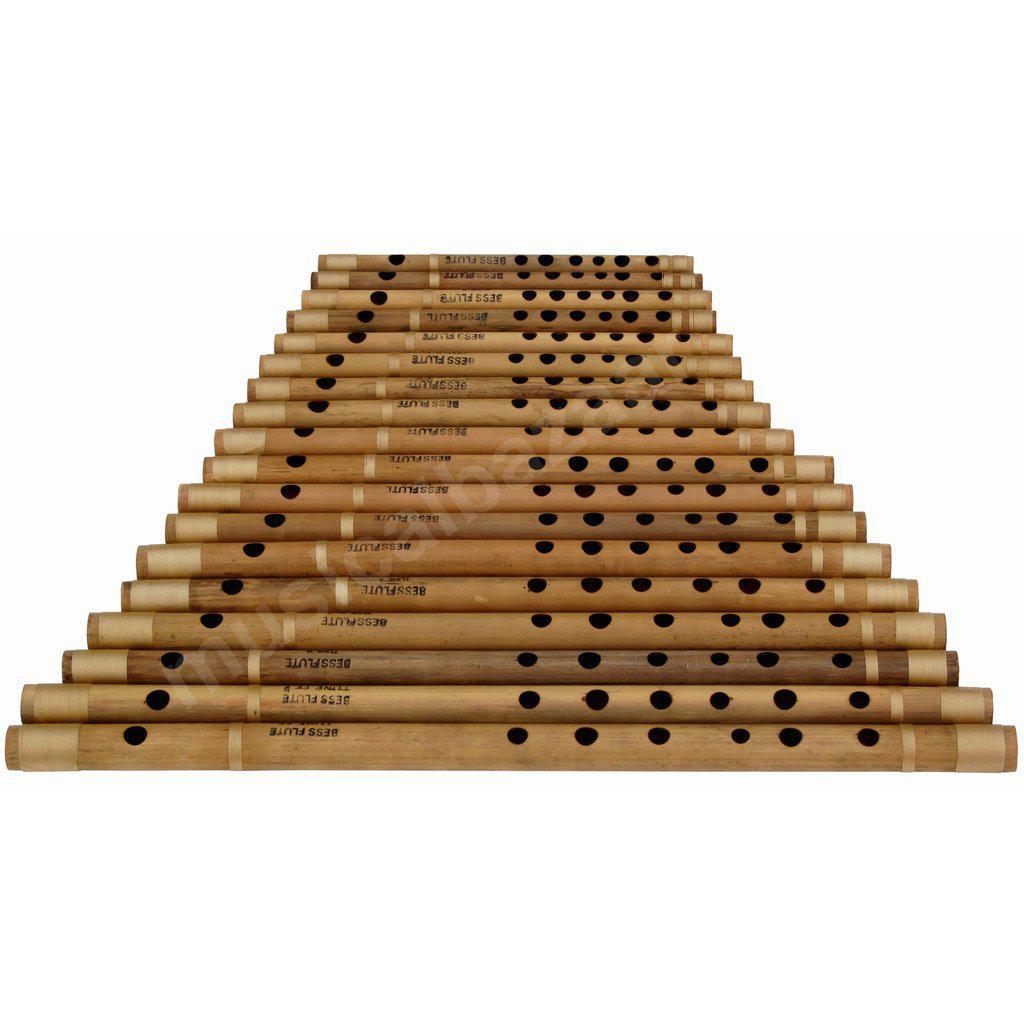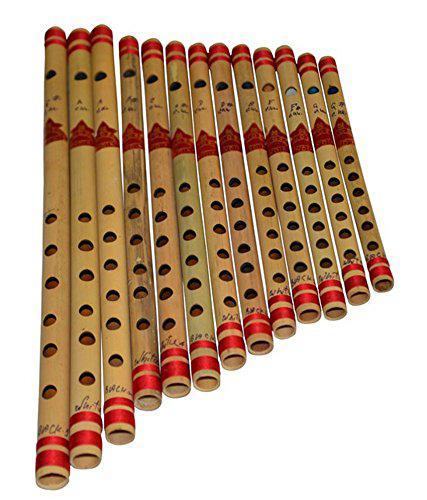The first image is the image on the left, the second image is the image on the right. Evaluate the accuracy of this statement regarding the images: "The right image shows a row of flutes with red stripes arranged in size order, with one end aligned.". Is it true? Answer yes or no. Yes. The first image is the image on the left, the second image is the image on the right. For the images displayed, is the sentence "At least 10 flutes are placed sided by side in each picture." factually correct? Answer yes or no. Yes. 